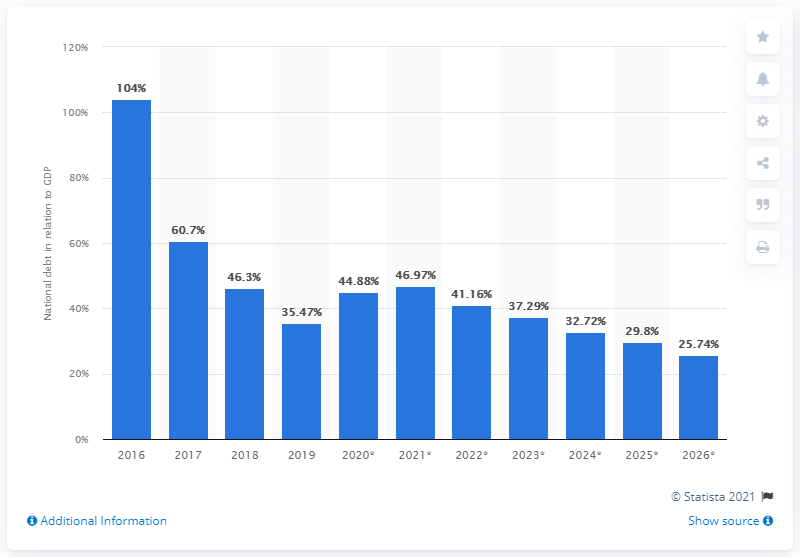Indicate a few pertinent items in this graphic. In 2019, the national debt of South Sudan accounted for approximately 35.47% of the country's Gross Domestic Product (GDP). 